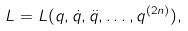Convert formula to latex. <formula><loc_0><loc_0><loc_500><loc_500>L = L ( q , \dot { q } , \ddot { q } , \dots , q ^ { ( 2 n ) } ) ,</formula> 